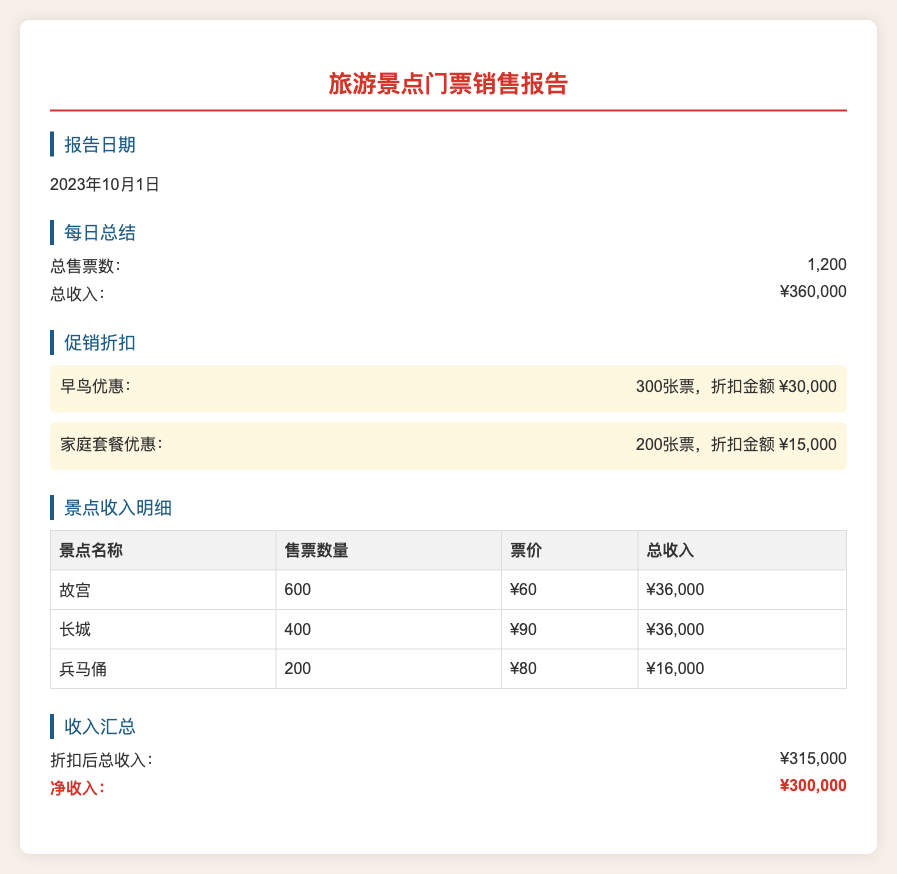总售票数是多少？ 总售票数是报告中明确列出的，该数值为1200。
Answer: 1,200 报告的日期是什么？ 报告日期在文档中标明为2023年10月1日。
Answer: 2023年10月1日 折扣后总收入是多少？ 折扣后总收入经过各项计算得出，为315,000元。
Answer: ¥315,000 早鸟优惠售出多少张票？ 早鸟优惠的售票数量为300张票。
Answer: 300张票 长城的总收入是多少？ 长城的总收入在收入明细表中列明，为36,000元。
Answer: ¥36,000 家庭套餐优惠的折扣金额是多少？ 家庭套餐优惠的折扣金额为15,000元，文档中有详细描述。
Answer: ¥15,000 净收入是多少？ 净收入是扣除各种折扣后的最终收入，文档中表明为300,000元。
Answer: ¥300,000 兵马俑的票价是多少？ 兵马俑的票价在文档中列出，为80元。
Answer: ¥80 促销有哪些类型？ 促销类型包括早鸟优惠和家庭套餐优惠，这在文档的相关部分有所提到。
Answer: 早鸟优惠，家庭套餐优惠 